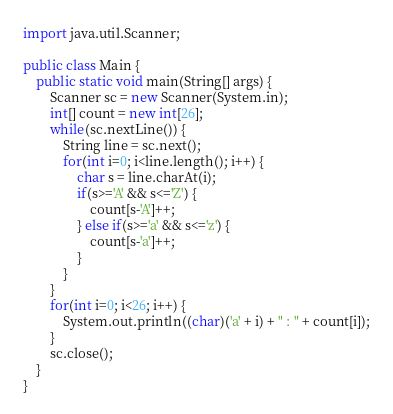<code> <loc_0><loc_0><loc_500><loc_500><_Java_>import java.util.Scanner;

public class Main {
	public static void main(String[] args) {
		Scanner sc = new Scanner(System.in);
		int[] count = new int[26];
		while(sc.nextLine()) {
			String line = sc.next();
			for(int i=0; i<line.length(); i++) {
				char s = line.charAt(i);
				if(s>='A' && s<='Z') {
					count[s-'A']++;
				} else if(s>='a' && s<='z') {
					count[s-'a']++;
				}
			}
		}
		for(int i=0; i<26; i++) {
			System.out.println((char)('a' + i) + " : " + count[i]);
		}
		sc.close();
	}
}</code> 